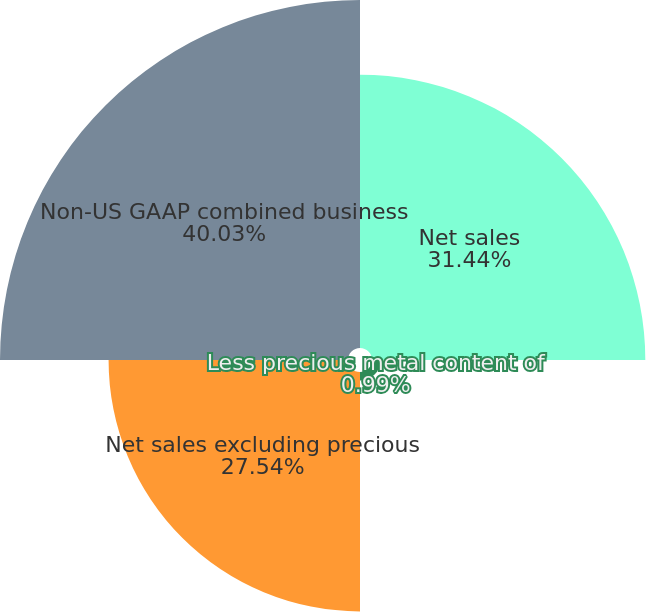<chart> <loc_0><loc_0><loc_500><loc_500><pie_chart><fcel>Net sales<fcel>Less precious metal content of<fcel>Net sales excluding precious<fcel>Non-US GAAP combined business<nl><fcel>31.44%<fcel>0.99%<fcel>27.54%<fcel>40.03%<nl></chart> 